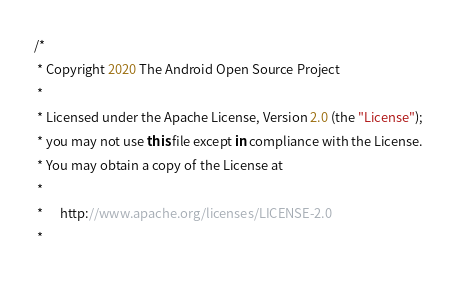<code> <loc_0><loc_0><loc_500><loc_500><_Kotlin_>/*
 * Copyright 2020 The Android Open Source Project
 *
 * Licensed under the Apache License, Version 2.0 (the "License");
 * you may not use this file except in compliance with the License.
 * You may obtain a copy of the License at
 *
 *      http://www.apache.org/licenses/LICENSE-2.0
 *</code> 